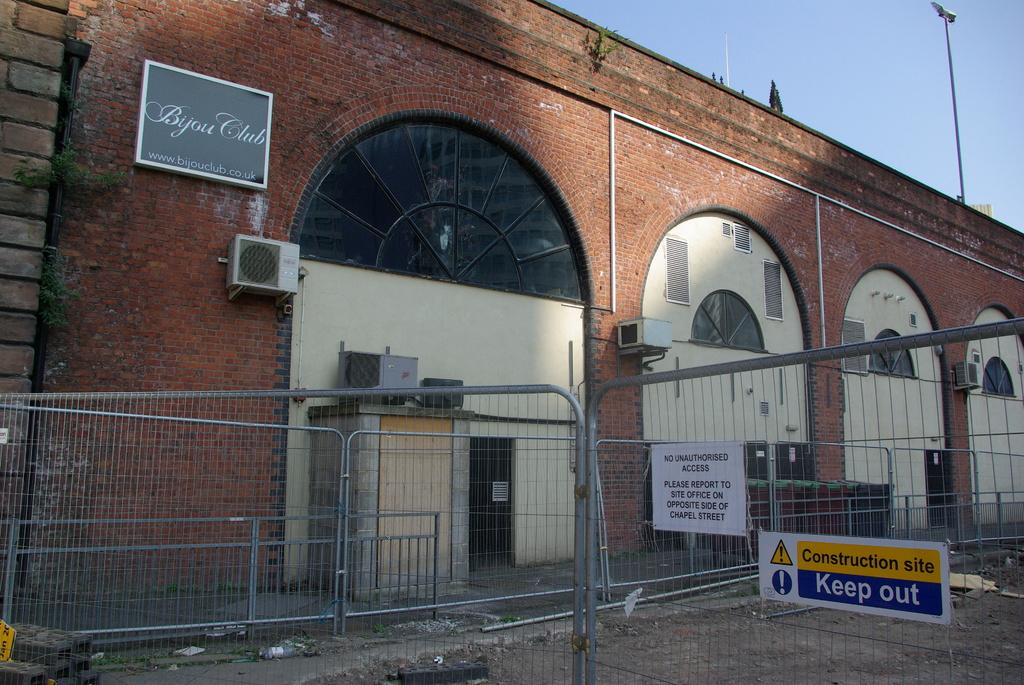What type of material is used for the wall in the image? The wall in the image is made of bricks. What can be seen near the wall in the image? There is a railing near the wall in the image. What is on top of the wall in the image? There is a pole on top of the wall in the image. What is visible behind the pole in the image? The sky is visible behind the pole in the image. What type of science experiment is being conducted on the wall in the image? There is no science experiment being conducted in the image; it only shows a wall with bricks, a railing, a pole, and the sky. 